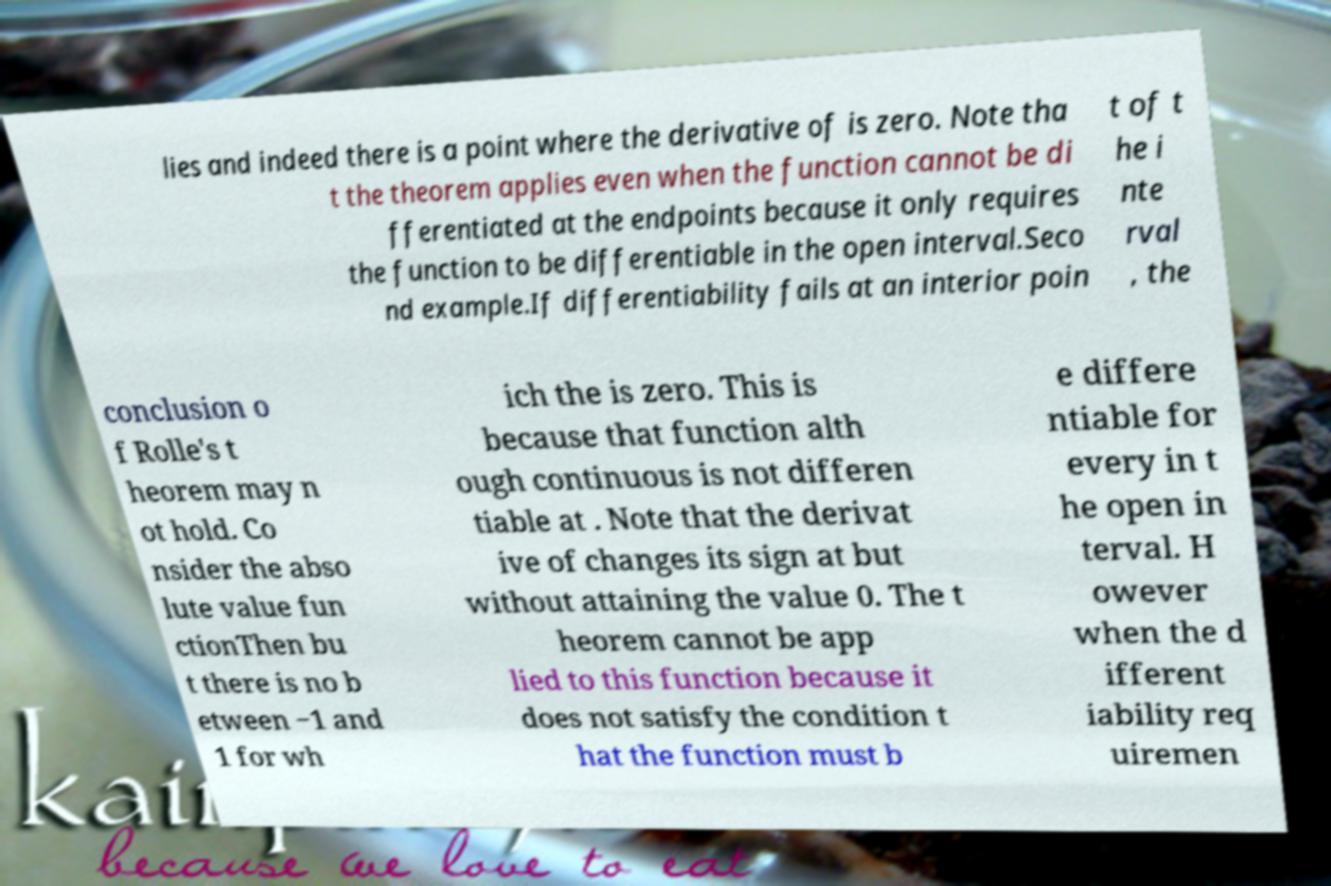Can you read and provide the text displayed in the image?This photo seems to have some interesting text. Can you extract and type it out for me? lies and indeed there is a point where the derivative of is zero. Note tha t the theorem applies even when the function cannot be di fferentiated at the endpoints because it only requires the function to be differentiable in the open interval.Seco nd example.If differentiability fails at an interior poin t of t he i nte rval , the conclusion o f Rolle's t heorem may n ot hold. Co nsider the abso lute value fun ctionThen bu t there is no b etween −1 and 1 for wh ich the is zero. This is because that function alth ough continuous is not differen tiable at . Note that the derivat ive of changes its sign at but without attaining the value 0. The t heorem cannot be app lied to this function because it does not satisfy the condition t hat the function must b e differe ntiable for every in t he open in terval. H owever when the d ifferent iability req uiremen 